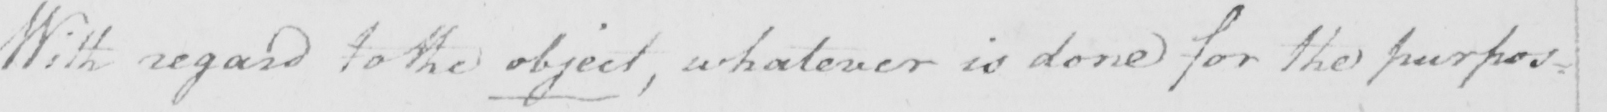Can you read and transcribe this handwriting? With regard to the object , whatever is done for the purpos= 